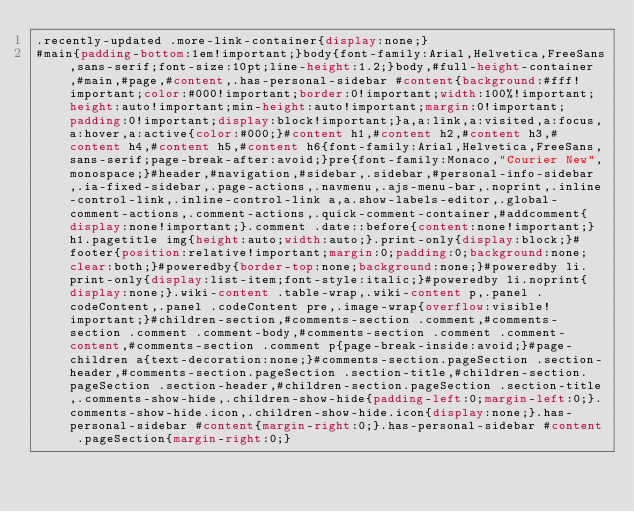<code> <loc_0><loc_0><loc_500><loc_500><_CSS_>.recently-updated .more-link-container{display:none;}
#main{padding-bottom:1em!important;}body{font-family:Arial,Helvetica,FreeSans,sans-serif;font-size:10pt;line-height:1.2;}body,#full-height-container,#main,#page,#content,.has-personal-sidebar #content{background:#fff!important;color:#000!important;border:0!important;width:100%!important;height:auto!important;min-height:auto!important;margin:0!important;padding:0!important;display:block!important;}a,a:link,a:visited,a:focus,a:hover,a:active{color:#000;}#content h1,#content h2,#content h3,#content h4,#content h5,#content h6{font-family:Arial,Helvetica,FreeSans,sans-serif;page-break-after:avoid;}pre{font-family:Monaco,"Courier New",monospace;}#header,#navigation,#sidebar,.sidebar,#personal-info-sidebar,.ia-fixed-sidebar,.page-actions,.navmenu,.ajs-menu-bar,.noprint,.inline-control-link,.inline-control-link a,a.show-labels-editor,.global-comment-actions,.comment-actions,.quick-comment-container,#addcomment{display:none!important;}.comment .date::before{content:none!important;}h1.pagetitle img{height:auto;width:auto;}.print-only{display:block;}#footer{position:relative!important;margin:0;padding:0;background:none;clear:both;}#poweredby{border-top:none;background:none;}#poweredby li.print-only{display:list-item;font-style:italic;}#poweredby li.noprint{display:none;}.wiki-content .table-wrap,.wiki-content p,.panel .codeContent,.panel .codeContent pre,.image-wrap{overflow:visible!important;}#children-section,#comments-section .comment,#comments-section .comment .comment-body,#comments-section .comment .comment-content,#comments-section .comment p{page-break-inside:avoid;}#page-children a{text-decoration:none;}#comments-section.pageSection .section-header,#comments-section.pageSection .section-title,#children-section.pageSection .section-header,#children-section.pageSection .section-title,.comments-show-hide,.children-show-hide{padding-left:0;margin-left:0;}.comments-show-hide.icon,.children-show-hide.icon{display:none;}.has-personal-sidebar #content{margin-right:0;}.has-personal-sidebar #content .pageSection{margin-right:0;}
</code> 